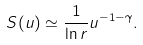Convert formula to latex. <formula><loc_0><loc_0><loc_500><loc_500>S ( u ) \simeq \frac { 1 } { \ln { r } } u ^ { - 1 - \gamma } .</formula> 